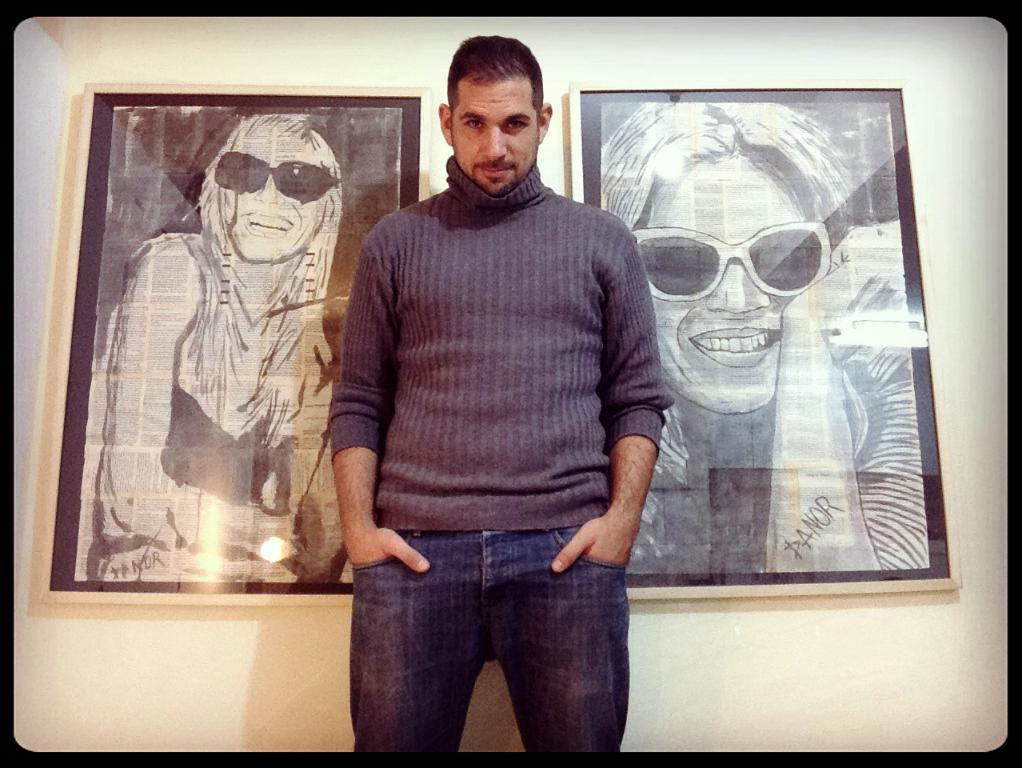Who is the main subject in the picture? There is a man in the picture. What is the man wearing in the image? The man is wearing a sweater. What is the man doing in the picture? The man is standing in the front and posing for the camera. What can be seen in the background of the image? There are two photo frames hanging on the wall in the background. What type of card is the man holding in the image? There is no card present in the image; the man is posing for the camera while wearing a sweater. 